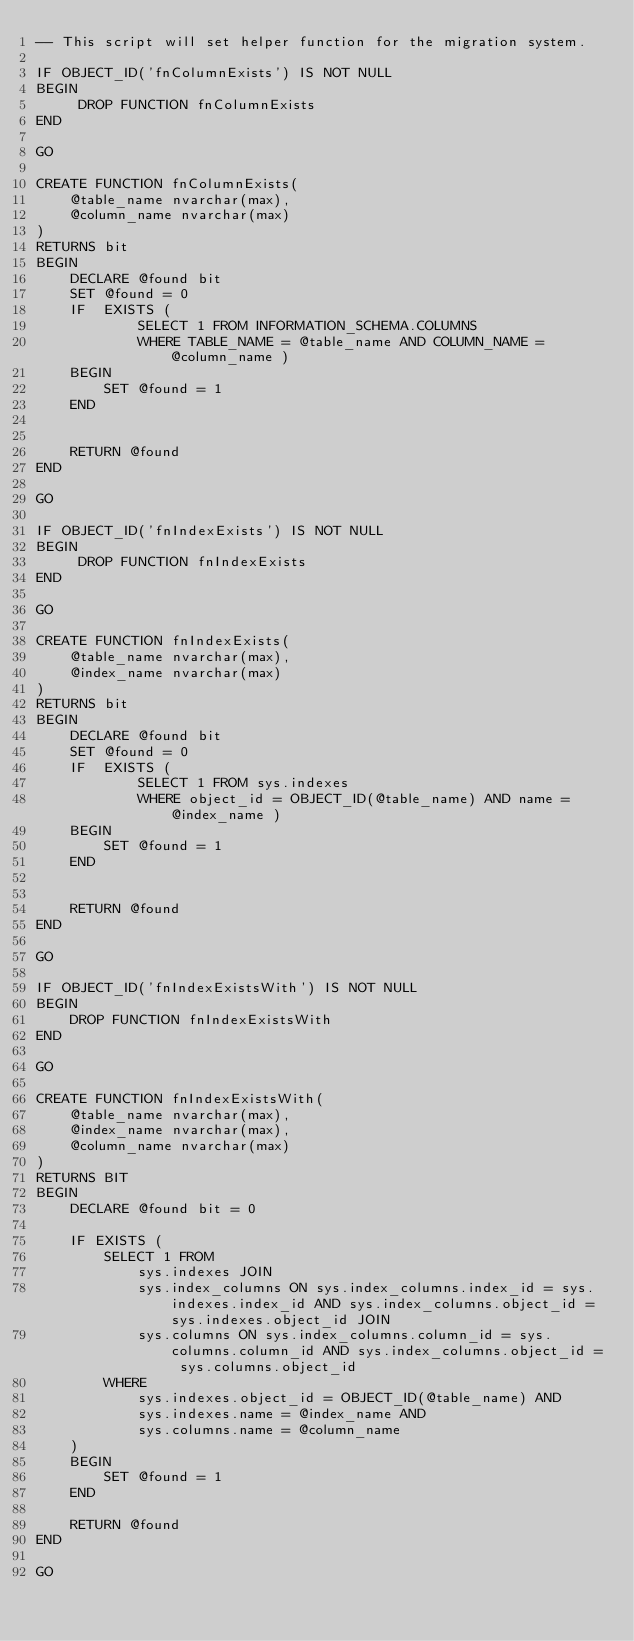Convert code to text. <code><loc_0><loc_0><loc_500><loc_500><_SQL_>-- This script will set helper function for the migration system.

IF OBJECT_ID('fnColumnExists') IS NOT NULL
BEGIN
	 DROP FUNCTION fnColumnExists
END 

GO

CREATE FUNCTION fnColumnExists(
	@table_name nvarchar(max),
	@column_name nvarchar(max) 
)
RETURNS bit 
BEGIN  
	DECLARE @found bit
	SET @found = 0
	IF	EXISTS (
			SELECT 1 FROM INFORMATION_SCHEMA.COLUMNS 
			WHERE TABLE_NAME = @table_name AND COLUMN_NAME = @column_name ) 
	BEGIN
		SET @found = 1
	END
	 
	
	RETURN @found
END
 
GO 

IF OBJECT_ID('fnIndexExists') IS NOT NULL
BEGIN
	 DROP FUNCTION fnIndexExists
END 

GO

CREATE FUNCTION fnIndexExists(
	@table_name nvarchar(max),
	@index_name nvarchar(max) 
)
RETURNS bit 
BEGIN  
	DECLARE @found bit
	SET @found = 0
	IF	EXISTS (
			SELECT 1 FROM sys.indexes
			WHERE object_id = OBJECT_ID(@table_name) AND name = @index_name ) 
	BEGIN
		SET @found = 1
	END
	 
	
	RETURN @found
END

GO

IF OBJECT_ID('fnIndexExistsWith') IS NOT NULL
BEGIN
	DROP FUNCTION fnIndexExistsWith
END

GO

CREATE FUNCTION fnIndexExistsWith(
	@table_name nvarchar(max),
	@index_name nvarchar(max),
	@column_name nvarchar(max)
)
RETURNS BIT
BEGIN
	DECLARE @found bit = 0
	
	IF EXISTS (
		SELECT 1 FROM
			sys.indexes JOIN
			sys.index_columns ON sys.index_columns.index_id = sys.indexes.index_id AND sys.index_columns.object_id = sys.indexes.object_id JOIN
			sys.columns ON sys.index_columns.column_id = sys.columns.column_id AND sys.index_columns.object_id = sys.columns.object_id
		WHERE
			sys.indexes.object_id = OBJECT_ID(@table_name) AND
			sys.indexes.name = @index_name AND
			sys.columns.name = @column_name
	)
	BEGIN
		SET @found = 1
	END
	
	RETURN @found
END

GO</code> 